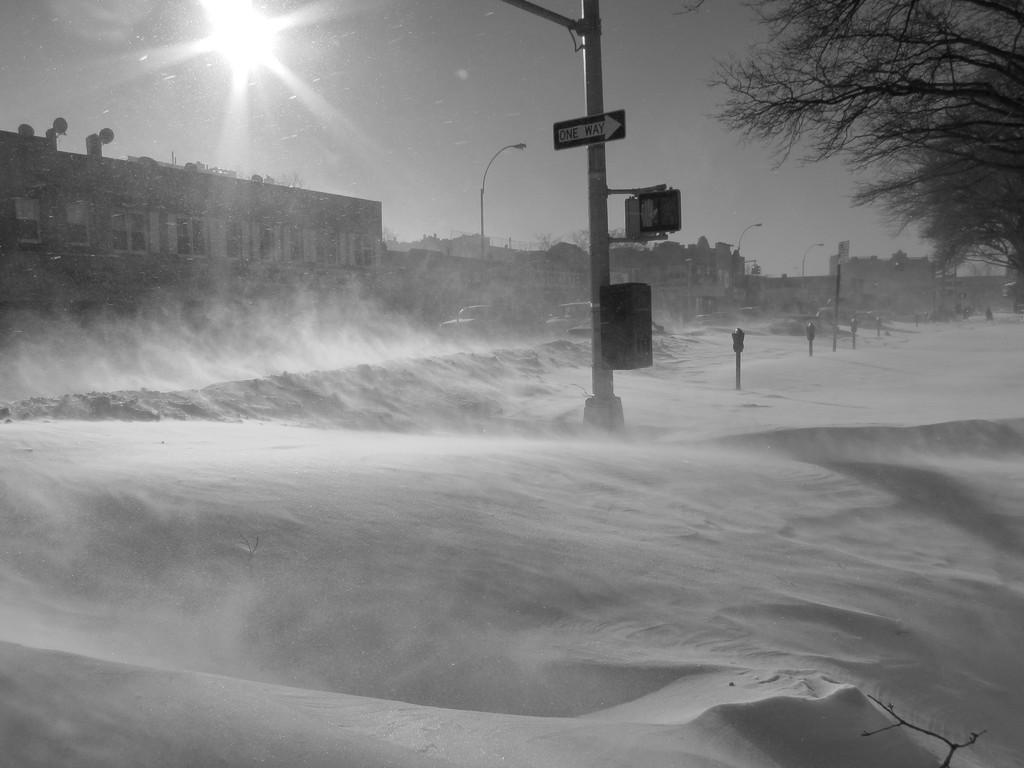What is the color scheme of the image? The image is black and white. What type of weather is depicted in the image? There is snow in the image. What structures can be seen in the image? There are poles and a sign board in the image. What can be seen in the background of the image? The background of the image includes buildings, vehicles, street lights, trees, and the sky. What type of cloth is draped over the poles in the image? There is no cloth draped over the poles in the image; the poles are standing without any cloth. What is the position of the cellar in the image? There is no cellar present in the image. 